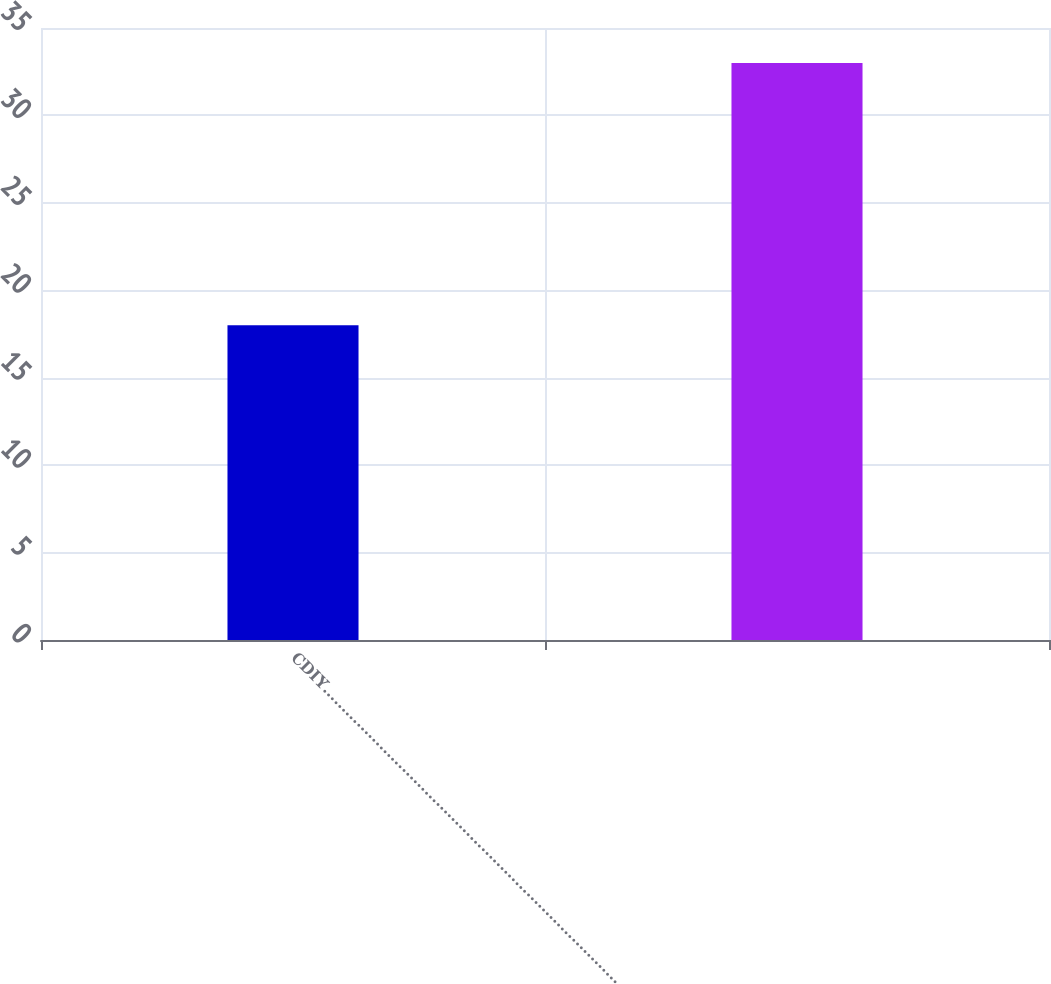Convert chart. <chart><loc_0><loc_0><loc_500><loc_500><bar_chart><fcel>CDIY……………………………………………………………………<fcel>Unnamed: 1<nl><fcel>18<fcel>33<nl></chart> 